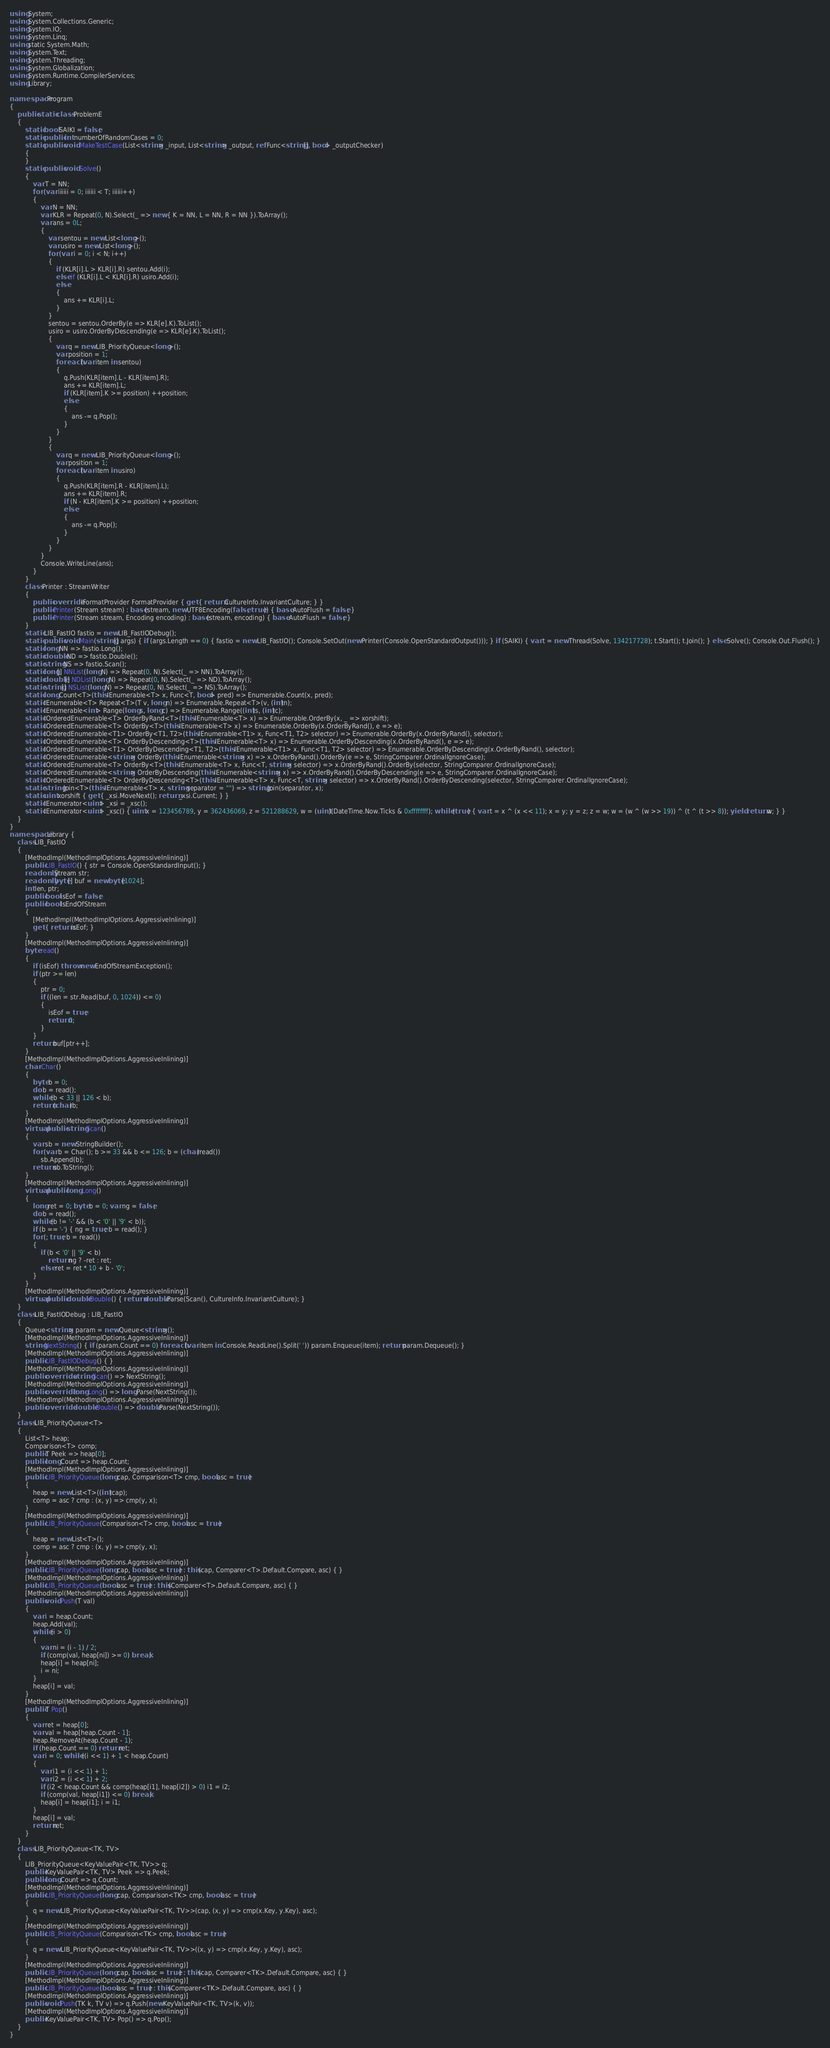Convert code to text. <code><loc_0><loc_0><loc_500><loc_500><_C#_>using System;
using System.Collections.Generic;
using System.IO;
using System.Linq;
using static System.Math;
using System.Text;
using System.Threading;
using System.Globalization;
using System.Runtime.CompilerServices;
using Library;

namespace Program
{
    public static class ProblemE
    {
        static bool SAIKI = false;
        static public int numberOfRandomCases = 0;
        static public void MakeTestCase(List<string> _input, List<string> _output, ref Func<string[], bool> _outputChecker)
        {
        }
        static public void Solve()
        {
            var T = NN;
            for (var iiiiii = 0; iiiiii < T; iiiiii++)
            {
                var N = NN;
                var KLR = Repeat(0, N).Select(_ => new { K = NN, L = NN, R = NN }).ToArray();
                var ans = 0L;
                {
                    var sentou = new List<long>();
                    var usiro = new List<long>();
                    for (var i = 0; i < N; i++)
                    {
                        if (KLR[i].L > KLR[i].R) sentou.Add(i);
                        else if (KLR[i].L < KLR[i].R) usiro.Add(i);
                        else
                        {
                            ans += KLR[i].L;
                        }
                    }
                    sentou = sentou.OrderBy(e => KLR[e].K).ToList();
                    usiro = usiro.OrderByDescending(e => KLR[e].K).ToList();
                    {
                        var q = new LIB_PriorityQueue<long>();
                        var position = 1;
                        foreach (var item in sentou)
                        {
                            q.Push(KLR[item].L - KLR[item].R);
                            ans += KLR[item].L;
                            if (KLR[item].K >= position) ++position;
                            else
                            {
                                ans -= q.Pop();
                            }
                        }
                    }
                    {
                        var q = new LIB_PriorityQueue<long>();
                        var position = 1;
                        foreach (var item in usiro)
                        {
                            q.Push(KLR[item].R - KLR[item].L);
                            ans += KLR[item].R;
                            if (N - KLR[item].K >= position) ++position;
                            else
                            {
                                ans -= q.Pop();
                            }
                        }
                    }
                }
                Console.WriteLine(ans);
            }
        }
        class Printer : StreamWriter
        {
            public override IFormatProvider FormatProvider { get { return CultureInfo.InvariantCulture; } }
            public Printer(Stream stream) : base(stream, new UTF8Encoding(false, true)) { base.AutoFlush = false; }
            public Printer(Stream stream, Encoding encoding) : base(stream, encoding) { base.AutoFlush = false; }
        }
        static LIB_FastIO fastio = new LIB_FastIODebug();
        static public void Main(string[] args) { if (args.Length == 0) { fastio = new LIB_FastIO(); Console.SetOut(new Printer(Console.OpenStandardOutput())); } if (SAIKI) { var t = new Thread(Solve, 134217728); t.Start(); t.Join(); } else Solve(); Console.Out.Flush(); }
        static long NN => fastio.Long();
        static double ND => fastio.Double();
        static string NS => fastio.Scan();
        static long[] NNList(long N) => Repeat(0, N).Select(_ => NN).ToArray();
        static double[] NDList(long N) => Repeat(0, N).Select(_ => ND).ToArray();
        static string[] NSList(long N) => Repeat(0, N).Select(_ => NS).ToArray();
        static long Count<T>(this IEnumerable<T> x, Func<T, bool> pred) => Enumerable.Count(x, pred);
        static IEnumerable<T> Repeat<T>(T v, long n) => Enumerable.Repeat<T>(v, (int)n);
        static IEnumerable<int> Range(long s, long c) => Enumerable.Range((int)s, (int)c);
        static IOrderedEnumerable<T> OrderByRand<T>(this IEnumerable<T> x) => Enumerable.OrderBy(x, _ => xorshift);
        static IOrderedEnumerable<T> OrderBy<T>(this IEnumerable<T> x) => Enumerable.OrderBy(x.OrderByRand(), e => e);
        static IOrderedEnumerable<T1> OrderBy<T1, T2>(this IEnumerable<T1> x, Func<T1, T2> selector) => Enumerable.OrderBy(x.OrderByRand(), selector);
        static IOrderedEnumerable<T> OrderByDescending<T>(this IEnumerable<T> x) => Enumerable.OrderByDescending(x.OrderByRand(), e => e);
        static IOrderedEnumerable<T1> OrderByDescending<T1, T2>(this IEnumerable<T1> x, Func<T1, T2> selector) => Enumerable.OrderByDescending(x.OrderByRand(), selector);
        static IOrderedEnumerable<string> OrderBy(this IEnumerable<string> x) => x.OrderByRand().OrderBy(e => e, StringComparer.OrdinalIgnoreCase);
        static IOrderedEnumerable<T> OrderBy<T>(this IEnumerable<T> x, Func<T, string> selector) => x.OrderByRand().OrderBy(selector, StringComparer.OrdinalIgnoreCase);
        static IOrderedEnumerable<string> OrderByDescending(this IEnumerable<string> x) => x.OrderByRand().OrderByDescending(e => e, StringComparer.OrdinalIgnoreCase);
        static IOrderedEnumerable<T> OrderByDescending<T>(this IEnumerable<T> x, Func<T, string> selector) => x.OrderByRand().OrderByDescending(selector, StringComparer.OrdinalIgnoreCase);
        static string Join<T>(this IEnumerable<T> x, string separator = "") => string.Join(separator, x);
        static uint xorshift { get { _xsi.MoveNext(); return _xsi.Current; } }
        static IEnumerator<uint> _xsi = _xsc();
        static IEnumerator<uint> _xsc() { uint x = 123456789, y = 362436069, z = 521288629, w = (uint)(DateTime.Now.Ticks & 0xffffffff); while (true) { var t = x ^ (x << 11); x = y; y = z; z = w; w = (w ^ (w >> 19)) ^ (t ^ (t >> 8)); yield return w; } }
    }
}
namespace Library {
    class LIB_FastIO
    {
        [MethodImpl(MethodImplOptions.AggressiveInlining)]
        public LIB_FastIO() { str = Console.OpenStandardInput(); }
        readonly Stream str;
        readonly byte[] buf = new byte[1024];
        int len, ptr;
        public bool isEof = false;
        public bool IsEndOfStream
        {
            [MethodImpl(MethodImplOptions.AggressiveInlining)]
            get { return isEof; }
        }
        [MethodImpl(MethodImplOptions.AggressiveInlining)]
        byte read()
        {
            if (isEof) throw new EndOfStreamException();
            if (ptr >= len)
            {
                ptr = 0;
                if ((len = str.Read(buf, 0, 1024)) <= 0)
                {
                    isEof = true;
                    return 0;
                }
            }
            return buf[ptr++];
        }
        [MethodImpl(MethodImplOptions.AggressiveInlining)]
        char Char()
        {
            byte b = 0;
            do b = read();
            while (b < 33 || 126 < b);
            return (char)b;
        }
        [MethodImpl(MethodImplOptions.AggressiveInlining)]
        virtual public string Scan()
        {
            var sb = new StringBuilder();
            for (var b = Char(); b >= 33 && b <= 126; b = (char)read())
                sb.Append(b);
            return sb.ToString();
        }
        [MethodImpl(MethodImplOptions.AggressiveInlining)]
        virtual public long Long()
        {
            long ret = 0; byte b = 0; var ng = false;
            do b = read();
            while (b != '-' && (b < '0' || '9' < b));
            if (b == '-') { ng = true; b = read(); }
            for (; true; b = read())
            {
                if (b < '0' || '9' < b)
                    return ng ? -ret : ret;
                else ret = ret * 10 + b - '0';
            }
        }
        [MethodImpl(MethodImplOptions.AggressiveInlining)]
        virtual public double Double() { return double.Parse(Scan(), CultureInfo.InvariantCulture); }
    }
    class LIB_FastIODebug : LIB_FastIO
    {
        Queue<string> param = new Queue<string>();
        [MethodImpl(MethodImplOptions.AggressiveInlining)]
        string NextString() { if (param.Count == 0) foreach (var item in Console.ReadLine().Split(' ')) param.Enqueue(item); return param.Dequeue(); }
        [MethodImpl(MethodImplOptions.AggressiveInlining)]
        public LIB_FastIODebug() { }
        [MethodImpl(MethodImplOptions.AggressiveInlining)]
        public override string Scan() => NextString();
        [MethodImpl(MethodImplOptions.AggressiveInlining)]
        public override long Long() => long.Parse(NextString());
        [MethodImpl(MethodImplOptions.AggressiveInlining)]
        public override double Double() => double.Parse(NextString());
    }
    class LIB_PriorityQueue<T>
    {
        List<T> heap;
        Comparison<T> comp;
        public T Peek => heap[0];
        public long Count => heap.Count;
        [MethodImpl(MethodImplOptions.AggressiveInlining)]
        public LIB_PriorityQueue(long cap, Comparison<T> cmp, bool asc = true)
        {
            heap = new List<T>((int)cap);
            comp = asc ? cmp : (x, y) => cmp(y, x);
        }
        [MethodImpl(MethodImplOptions.AggressiveInlining)]
        public LIB_PriorityQueue(Comparison<T> cmp, bool asc = true)
        {
            heap = new List<T>();
            comp = asc ? cmp : (x, y) => cmp(y, x);
        }
        [MethodImpl(MethodImplOptions.AggressiveInlining)]
        public LIB_PriorityQueue(long cap, bool asc = true) : this(cap, Comparer<T>.Default.Compare, asc) { }
        [MethodImpl(MethodImplOptions.AggressiveInlining)]
        public LIB_PriorityQueue(bool asc = true) : this(Comparer<T>.Default.Compare, asc) { }
        [MethodImpl(MethodImplOptions.AggressiveInlining)]
        public void Push(T val)
        {
            var i = heap.Count;
            heap.Add(val);
            while (i > 0)
            {
                var ni = (i - 1) / 2;
                if (comp(val, heap[ni]) >= 0) break;
                heap[i] = heap[ni];
                i = ni;
            }
            heap[i] = val;
        }
        [MethodImpl(MethodImplOptions.AggressiveInlining)]
        public T Pop()
        {
            var ret = heap[0];
            var val = heap[heap.Count - 1];
            heap.RemoveAt(heap.Count - 1);
            if (heap.Count == 0) return ret;
            var i = 0; while ((i << 1) + 1 < heap.Count)
            {
                var i1 = (i << 1) + 1;
                var i2 = (i << 1) + 2;
                if (i2 < heap.Count && comp(heap[i1], heap[i2]) > 0) i1 = i2;
                if (comp(val, heap[i1]) <= 0) break;
                heap[i] = heap[i1]; i = i1;
            }
            heap[i] = val;
            return ret;
        }
    }
    class LIB_PriorityQueue<TK, TV>
    {
        LIB_PriorityQueue<KeyValuePair<TK, TV>> q;
        public KeyValuePair<TK, TV> Peek => q.Peek;
        public long Count => q.Count;
        [MethodImpl(MethodImplOptions.AggressiveInlining)]
        public LIB_PriorityQueue(long cap, Comparison<TK> cmp, bool asc = true)
        {
            q = new LIB_PriorityQueue<KeyValuePair<TK, TV>>(cap, (x, y) => cmp(x.Key, y.Key), asc);
        }
        [MethodImpl(MethodImplOptions.AggressiveInlining)]
        public LIB_PriorityQueue(Comparison<TK> cmp, bool asc = true)
        {
            q = new LIB_PriorityQueue<KeyValuePair<TK, TV>>((x, y) => cmp(x.Key, y.Key), asc);
        }
        [MethodImpl(MethodImplOptions.AggressiveInlining)]
        public LIB_PriorityQueue(long cap, bool asc = true) : this(cap, Comparer<TK>.Default.Compare, asc) { }
        [MethodImpl(MethodImplOptions.AggressiveInlining)]
        public LIB_PriorityQueue(bool asc = true) : this(Comparer<TK>.Default.Compare, asc) { }
        [MethodImpl(MethodImplOptions.AggressiveInlining)]
        public void Push(TK k, TV v) => q.Push(new KeyValuePair<TK, TV>(k, v));
        [MethodImpl(MethodImplOptions.AggressiveInlining)]
        public KeyValuePair<TK, TV> Pop() => q.Pop();
    }
}
</code> 